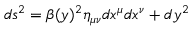<formula> <loc_0><loc_0><loc_500><loc_500>d s ^ { 2 } = \beta ( y ) ^ { 2 } \eta _ { \mu \nu } d x ^ { \mu } d x ^ { \nu } + d y ^ { 2 }</formula> 